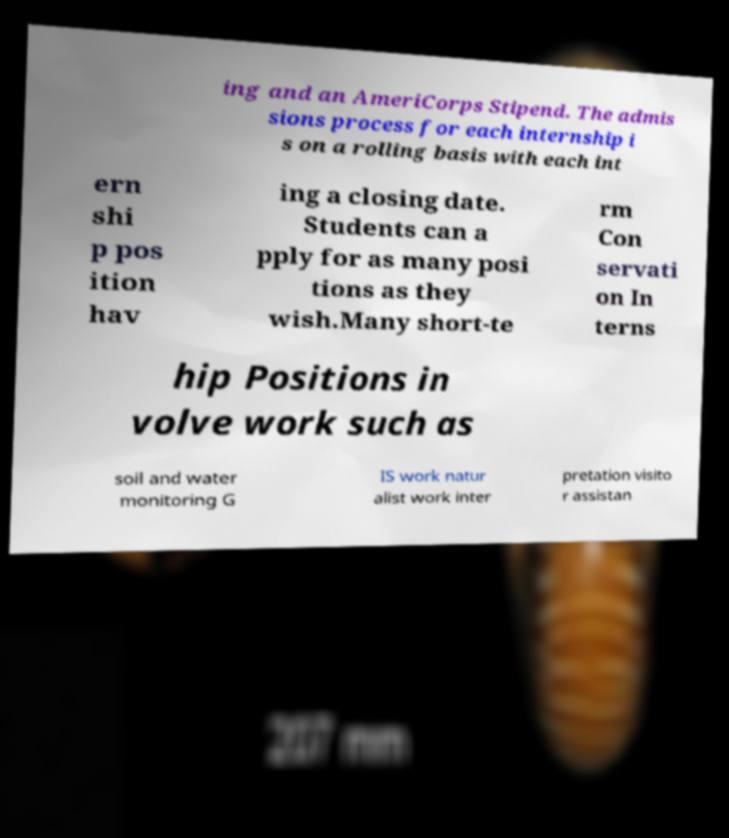I need the written content from this picture converted into text. Can you do that? ing and an AmeriCorps Stipend. The admis sions process for each internship i s on a rolling basis with each int ern shi p pos ition hav ing a closing date. Students can a pply for as many posi tions as they wish.Many short-te rm Con servati on In terns hip Positions in volve work such as soil and water monitoring G IS work natur alist work inter pretation visito r assistan 